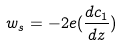<formula> <loc_0><loc_0><loc_500><loc_500>w _ { s } = - 2 e ( \frac { d c _ { 1 } } { d z } )</formula> 